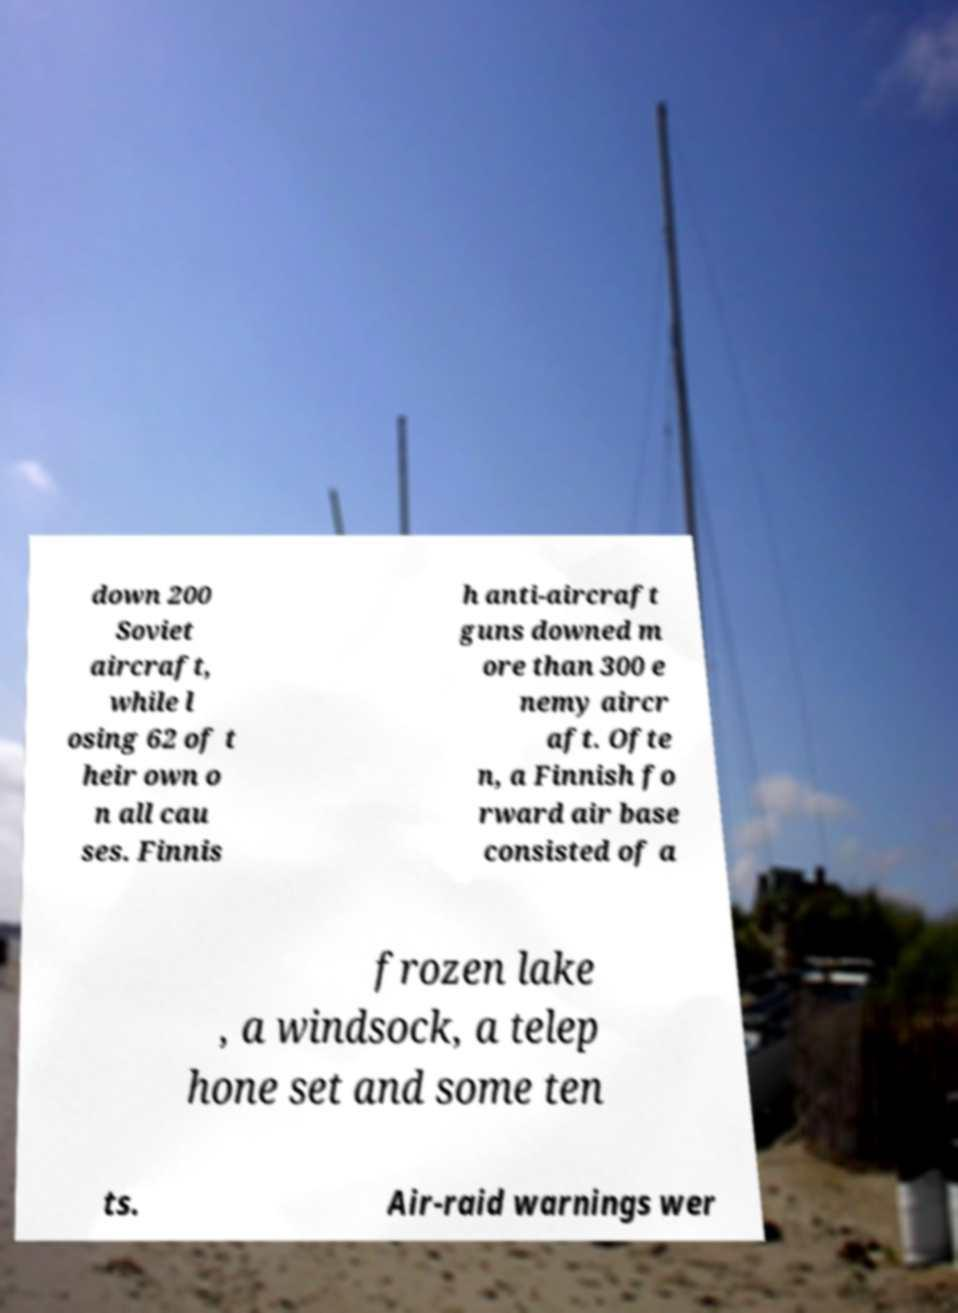What messages or text are displayed in this image? I need them in a readable, typed format. down 200 Soviet aircraft, while l osing 62 of t heir own o n all cau ses. Finnis h anti-aircraft guns downed m ore than 300 e nemy aircr aft. Ofte n, a Finnish fo rward air base consisted of a frozen lake , a windsock, a telep hone set and some ten ts. Air-raid warnings wer 